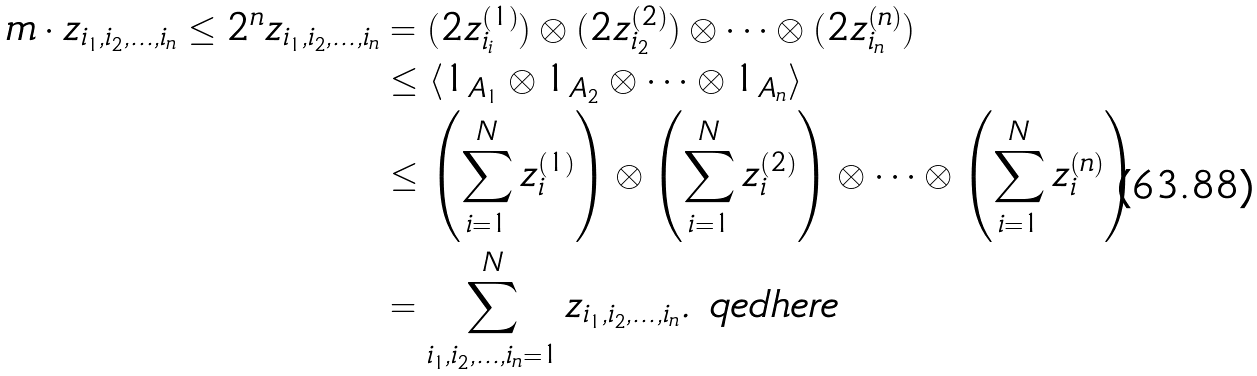Convert formula to latex. <formula><loc_0><loc_0><loc_500><loc_500>m \cdot z _ { i _ { 1 } , i _ { 2 } , \dots , i _ { n } } \leq 2 ^ { n } z _ { i _ { 1 } , i _ { 2 } , \dots , i _ { n } } & = ( 2 z ^ { ( 1 ) } _ { i _ { i } } ) \otimes ( 2 z ^ { ( 2 ) } _ { i _ { 2 } } ) \otimes \cdots \otimes ( 2 z ^ { ( n ) } _ { i _ { n } } ) \\ & \leq \langle 1 _ { A _ { 1 } } \otimes 1 _ { A _ { 2 } } \otimes \cdots \otimes 1 _ { A _ { n } } \rangle \\ & \leq \left ( \sum _ { i = 1 } ^ { N } z ^ { ( 1 ) } _ { i } \right ) \otimes \left ( \sum _ { i = 1 } ^ { N } z ^ { ( 2 ) } _ { i } \right ) \otimes \cdots \otimes \left ( \sum _ { i = 1 } ^ { N } z ^ { ( n ) } _ { i } \right ) \\ & = \sum _ { i _ { 1 } , i _ { 2 } , \dots , i _ { n } = 1 } ^ { N } z _ { i _ { 1 } , i _ { 2 } , \dots , i _ { n } } . \ q e d h e r e</formula> 